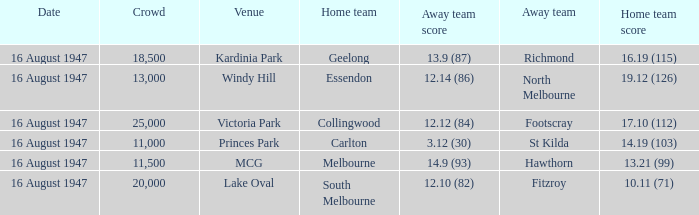What home team has had a crowd bigger than 20,000? Collingwood. 